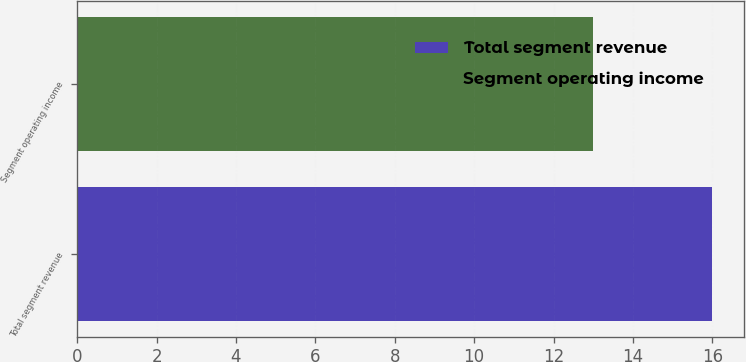<chart> <loc_0><loc_0><loc_500><loc_500><bar_chart><fcel>Total segment revenue<fcel>Segment operating income<nl><fcel>16<fcel>13<nl></chart> 